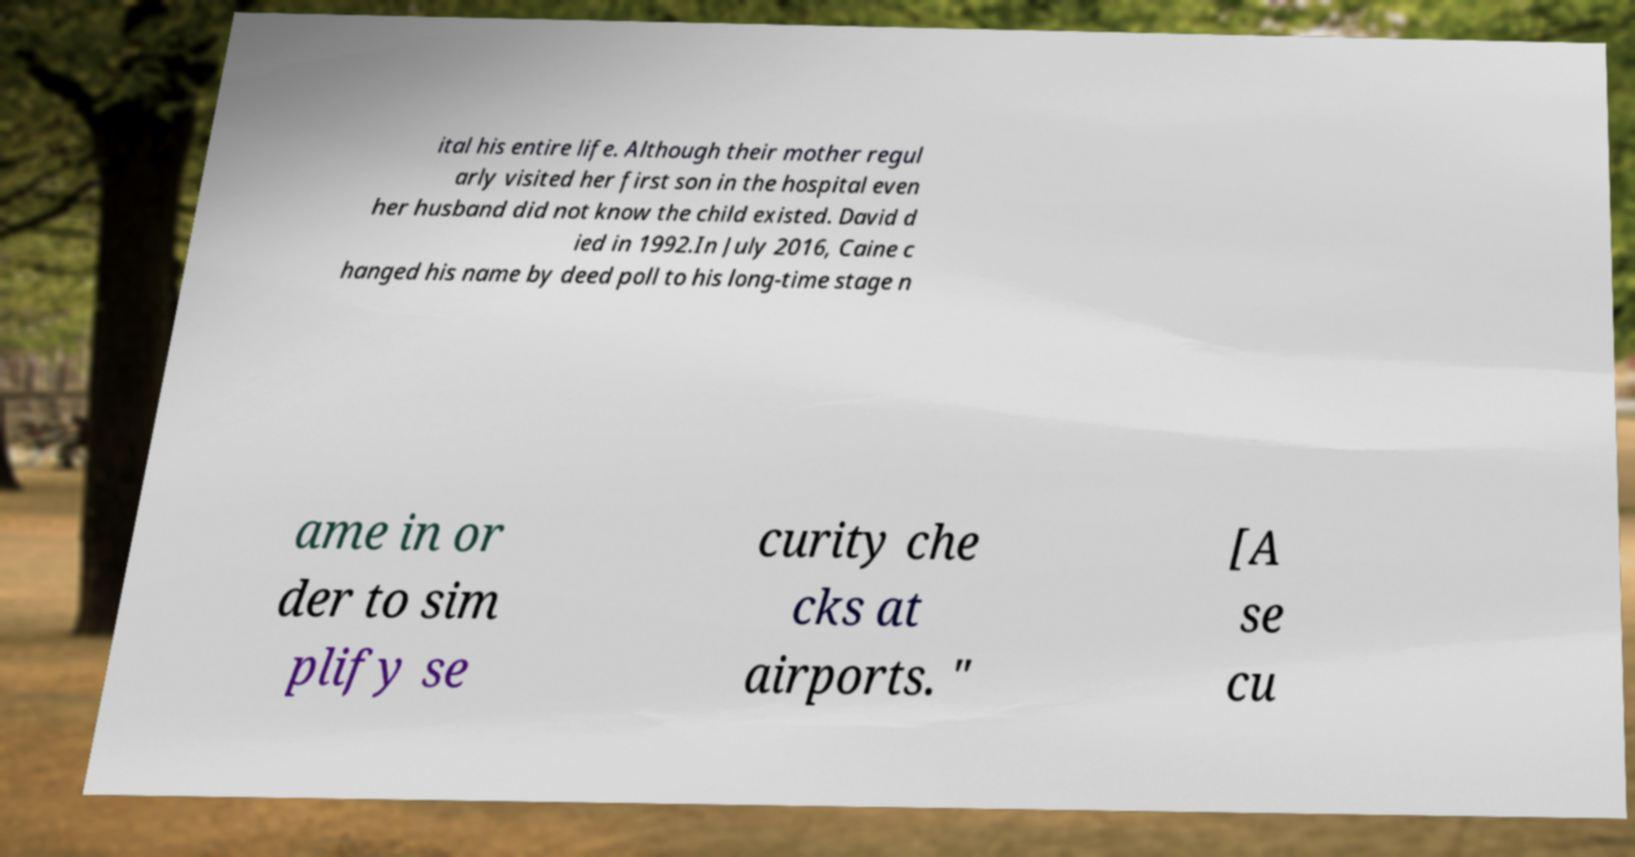Can you read and provide the text displayed in the image?This photo seems to have some interesting text. Can you extract and type it out for me? ital his entire life. Although their mother regul arly visited her first son in the hospital even her husband did not know the child existed. David d ied in 1992.In July 2016, Caine c hanged his name by deed poll to his long-time stage n ame in or der to sim plify se curity che cks at airports. " [A se cu 